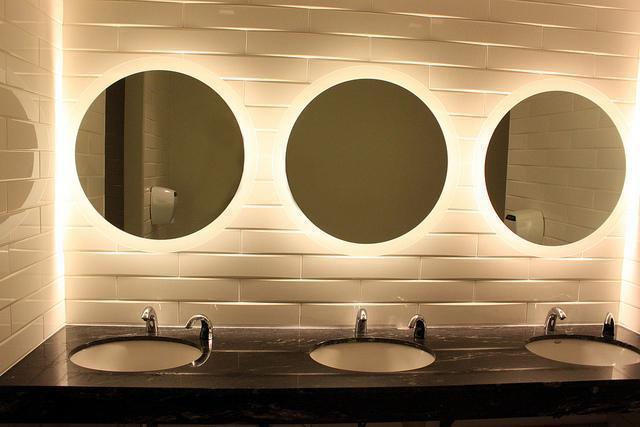How many sinks are on the row at this public bathroom area?
Indicate the correct response by choosing from the four available options to answer the question.
Options: One, four, two, three. Three. 